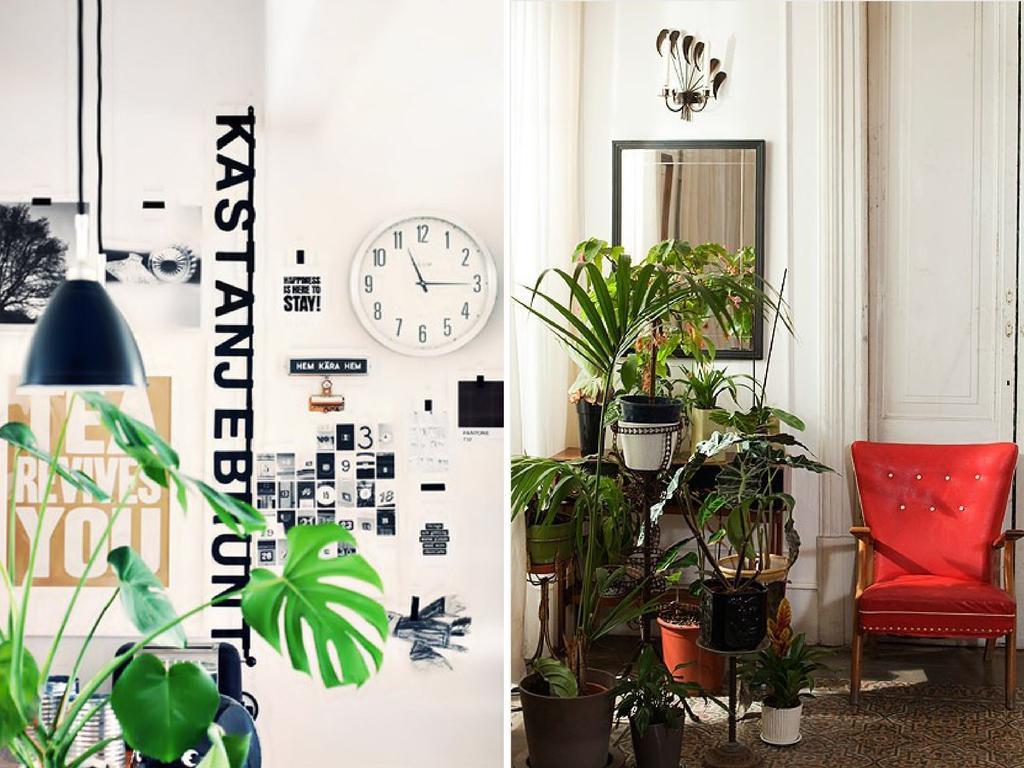Can you describe this image briefly? In this picture at the right side there is a sofa which is red in colour. In the center there are plants and wall clock attached to the wall. At the left side leaves of the plant is visible. In the background mirror is hanged on the wall and a white colour door. 